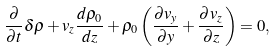<formula> <loc_0><loc_0><loc_500><loc_500>\frac { \partial } { \partial t } \delta \rho + v _ { z } \frac { d \rho _ { 0 } } { d z } + \rho _ { 0 } \left ( \frac { \partial v _ { y } } { \partial y } + \frac { \partial v _ { z } } { \partial z } \right ) = 0 ,</formula> 